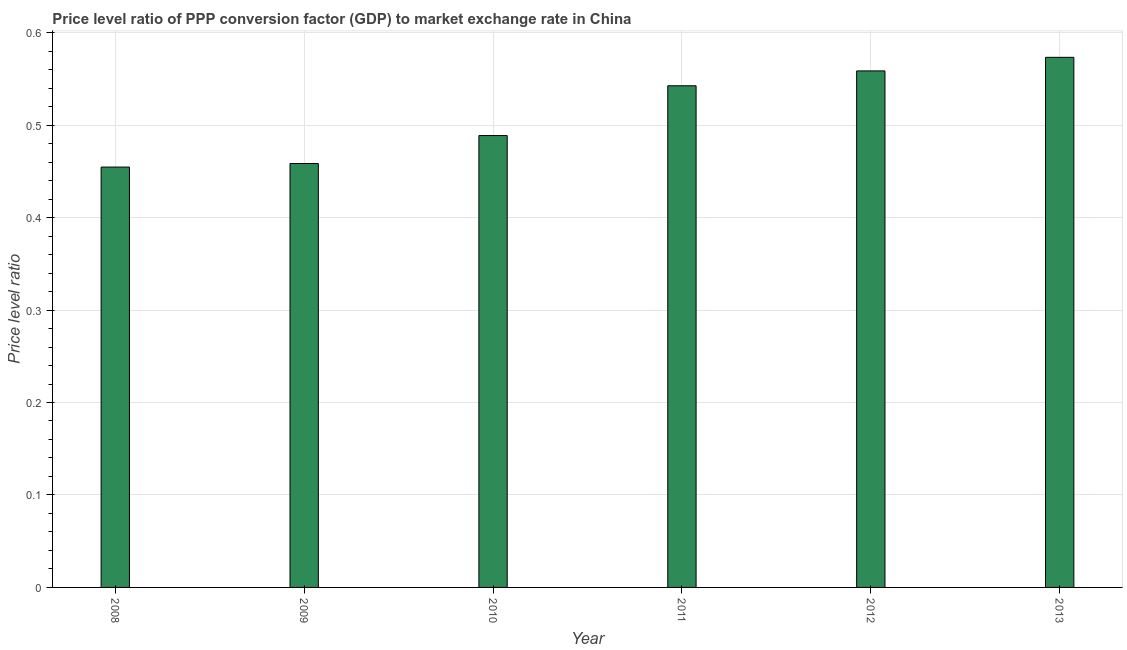Does the graph contain any zero values?
Offer a very short reply. No. What is the title of the graph?
Give a very brief answer. Price level ratio of PPP conversion factor (GDP) to market exchange rate in China. What is the label or title of the X-axis?
Ensure brevity in your answer.  Year. What is the label or title of the Y-axis?
Provide a short and direct response. Price level ratio. What is the price level ratio in 2011?
Provide a succinct answer. 0.54. Across all years, what is the maximum price level ratio?
Make the answer very short. 0.57. Across all years, what is the minimum price level ratio?
Your answer should be compact. 0.45. In which year was the price level ratio minimum?
Provide a succinct answer. 2008. What is the sum of the price level ratio?
Your answer should be compact. 3.08. What is the difference between the price level ratio in 2008 and 2013?
Provide a succinct answer. -0.12. What is the average price level ratio per year?
Offer a terse response. 0.51. What is the median price level ratio?
Your answer should be very brief. 0.52. In how many years, is the price level ratio greater than 0.54 ?
Your answer should be compact. 3. Do a majority of the years between 2010 and 2012 (inclusive) have price level ratio greater than 0.1 ?
Provide a short and direct response. Yes. What is the difference between the highest and the second highest price level ratio?
Provide a short and direct response. 0.01. What is the difference between the highest and the lowest price level ratio?
Give a very brief answer. 0.12. How many bars are there?
Offer a very short reply. 6. How many years are there in the graph?
Keep it short and to the point. 6. What is the Price level ratio of 2008?
Make the answer very short. 0.45. What is the Price level ratio in 2009?
Keep it short and to the point. 0.46. What is the Price level ratio of 2010?
Offer a very short reply. 0.49. What is the Price level ratio in 2011?
Your answer should be compact. 0.54. What is the Price level ratio in 2012?
Your response must be concise. 0.56. What is the Price level ratio in 2013?
Offer a terse response. 0.57. What is the difference between the Price level ratio in 2008 and 2009?
Your response must be concise. -0. What is the difference between the Price level ratio in 2008 and 2010?
Give a very brief answer. -0.03. What is the difference between the Price level ratio in 2008 and 2011?
Offer a very short reply. -0.09. What is the difference between the Price level ratio in 2008 and 2012?
Offer a very short reply. -0.1. What is the difference between the Price level ratio in 2008 and 2013?
Keep it short and to the point. -0.12. What is the difference between the Price level ratio in 2009 and 2010?
Your answer should be very brief. -0.03. What is the difference between the Price level ratio in 2009 and 2011?
Give a very brief answer. -0.08. What is the difference between the Price level ratio in 2009 and 2012?
Your answer should be compact. -0.1. What is the difference between the Price level ratio in 2009 and 2013?
Your response must be concise. -0.11. What is the difference between the Price level ratio in 2010 and 2011?
Offer a terse response. -0.05. What is the difference between the Price level ratio in 2010 and 2012?
Keep it short and to the point. -0.07. What is the difference between the Price level ratio in 2010 and 2013?
Give a very brief answer. -0.08. What is the difference between the Price level ratio in 2011 and 2012?
Offer a very short reply. -0.02. What is the difference between the Price level ratio in 2011 and 2013?
Your answer should be very brief. -0.03. What is the difference between the Price level ratio in 2012 and 2013?
Keep it short and to the point. -0.01. What is the ratio of the Price level ratio in 2008 to that in 2009?
Offer a very short reply. 0.99. What is the ratio of the Price level ratio in 2008 to that in 2010?
Your response must be concise. 0.93. What is the ratio of the Price level ratio in 2008 to that in 2011?
Ensure brevity in your answer.  0.84. What is the ratio of the Price level ratio in 2008 to that in 2012?
Keep it short and to the point. 0.81. What is the ratio of the Price level ratio in 2008 to that in 2013?
Offer a very short reply. 0.79. What is the ratio of the Price level ratio in 2009 to that in 2010?
Your response must be concise. 0.94. What is the ratio of the Price level ratio in 2009 to that in 2011?
Make the answer very short. 0.84. What is the ratio of the Price level ratio in 2009 to that in 2012?
Offer a terse response. 0.82. What is the ratio of the Price level ratio in 2010 to that in 2011?
Offer a terse response. 0.9. What is the ratio of the Price level ratio in 2010 to that in 2012?
Make the answer very short. 0.88. What is the ratio of the Price level ratio in 2010 to that in 2013?
Offer a very short reply. 0.85. What is the ratio of the Price level ratio in 2011 to that in 2013?
Provide a succinct answer. 0.95. 